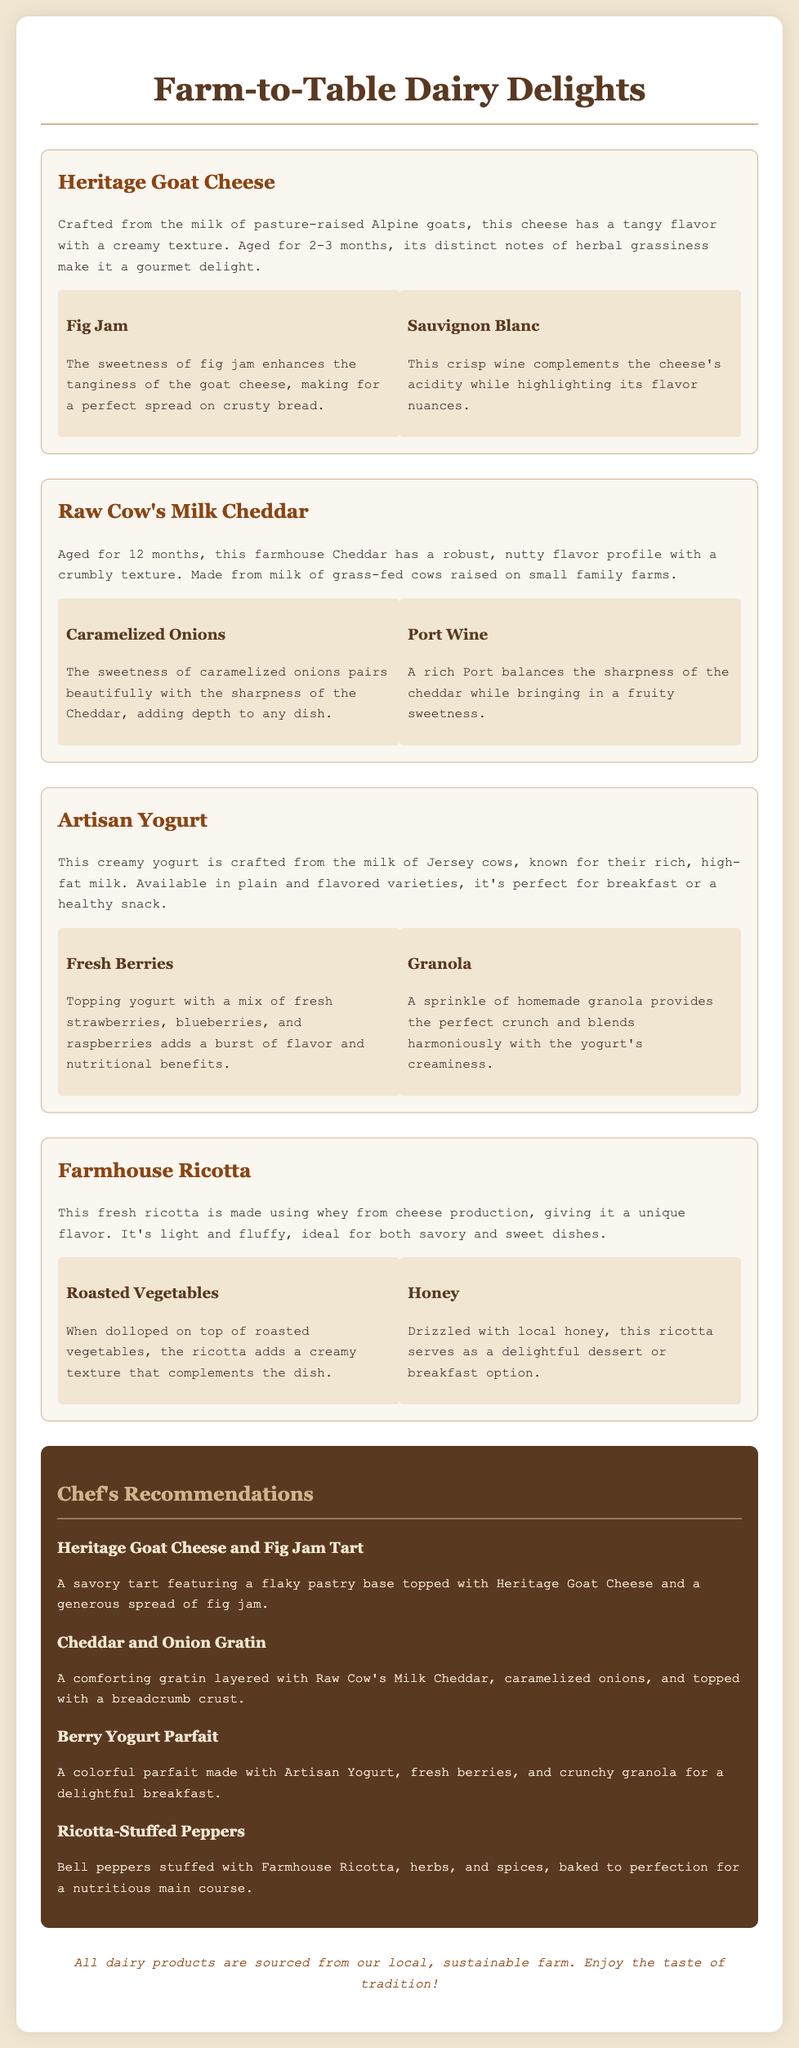What is the name of the goat cheese? The document lists "Heritage Goat Cheese" as the name of the cheese.
Answer: Heritage Goat Cheese How long is the goat cheese aged? The document states that the goat cheese is aged for 2-3 months.
Answer: 2-3 months What wine pairs well with the Raw Cow's Milk Cheddar? According to the document, Port Wine pairs well with the Cheddar.
Answer: Port Wine What is a chef's recommendation that includes yogurt? The document recommends "Berry Yogurt Parfait," which includes yogurt.
Answer: Berry Yogurt Parfait What flavor profile does the Raw Cow's Milk Cheddar have? The document describes the cheddar as having a robust, nutty flavor profile.
Answer: Robust, nutty Which dairy product is light and fluffy? The document states that "Farmhouse Ricotta" is light and fluffy.
Answer: Farmhouse Ricotta What is a suggested pairing for Artisan Yogurt? The document mentions "Fresh Berries" as a suggested pairing.
Answer: Fresh Berries What dish features the Heritage Goat Cheese? The document states the dish is "Heritage Goat Cheese and Fig Jam Tart."
Answer: Heritage Goat Cheese and Fig Jam Tart What type of milk is used for the Artisan Yogurt? According to the document, the yogurt is crafted from the milk of Jersey cows.
Answer: Jersey cows 